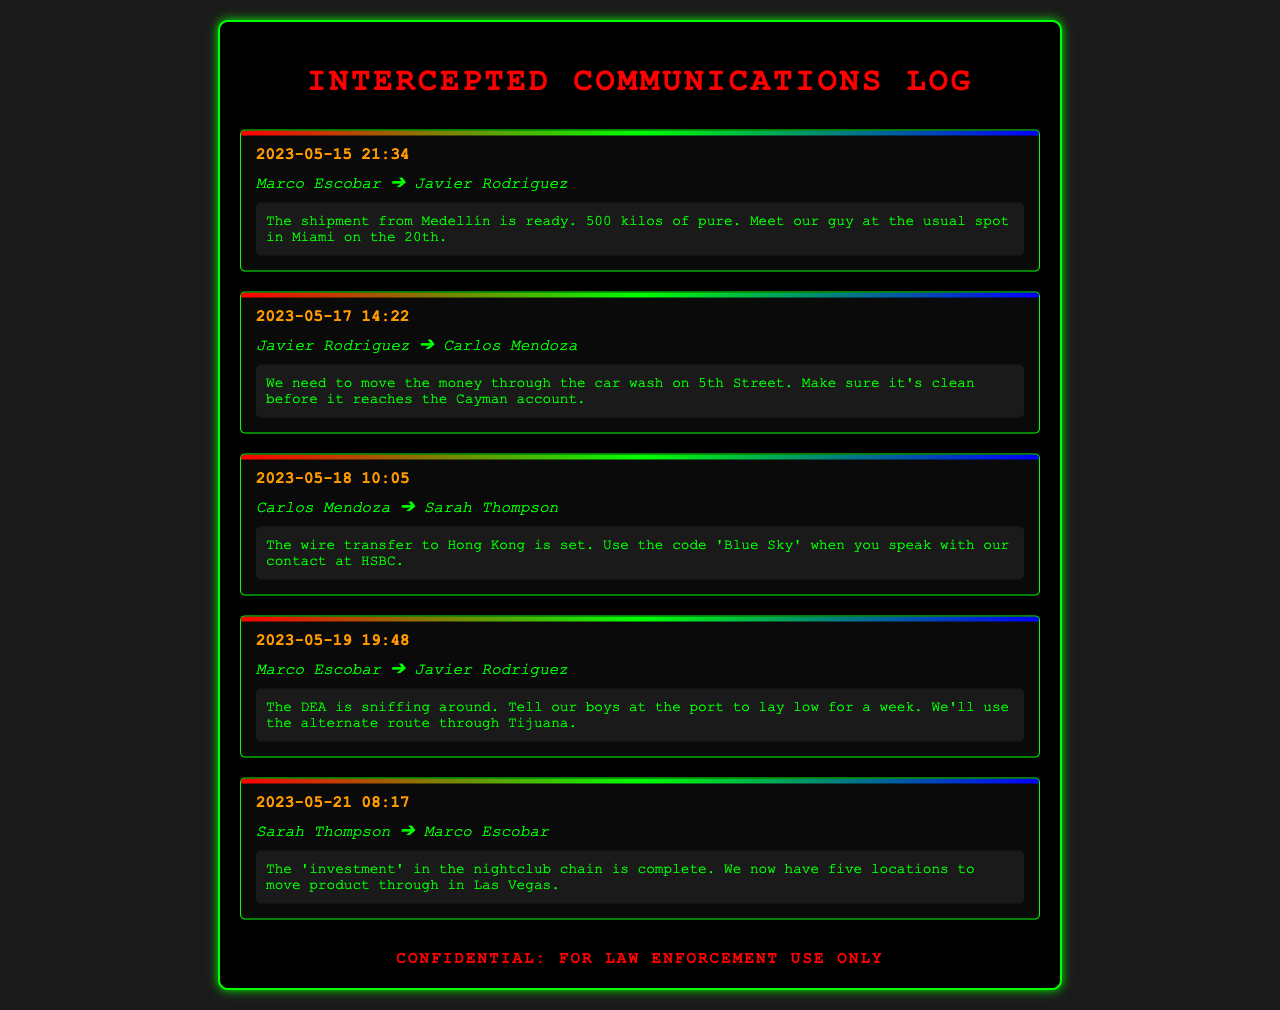What date is the shipment from Medellín ready? The specific date is mentioned in the first record of the document, which is May 15, 2023.
Answer: May 15, 2023 How many kilos of product are mentioned to be shipped? The quantity of product in the first record is clearly stated as 500 kilos.
Answer: 500 kilos Who is responsible for the wire transfer to Hong Kong? The record indicates that Carlos Mendoza is in charge of the wire transfer, as mentioned in the third record.
Answer: Carlos Mendoza What is the code to use when speaking with the HSBC contact? The document specifies that the code is 'Blue Sky' in the third record.
Answer: Blue Sky What is the total number of nightclub locations mentioned? Sarah Thompson states in the fifth record that five locations are now available for product movement.
Answer: five Why should the boys at the port lay low? Marco Escobar suggests that the DEA is sniffing around, which indicates the need for caution in the fourth record.
Answer: DEA Which alternate route is mentioned for drug transportation? The alternate route mentioned by Marco Escobar in the fourth record is through Tijuana.
Answer: Tijuana What is said to be completed in the nightclub chain? The term 'investment' is used in the fifth record to refer to the completion of work in the nightclub chain.
Answer: investment 